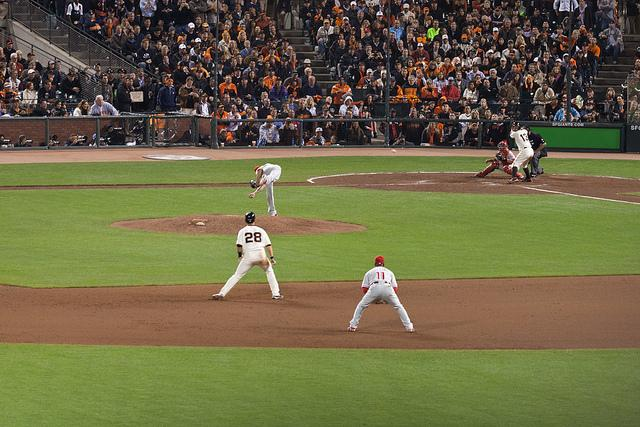Where does baseball come from? pitcher 